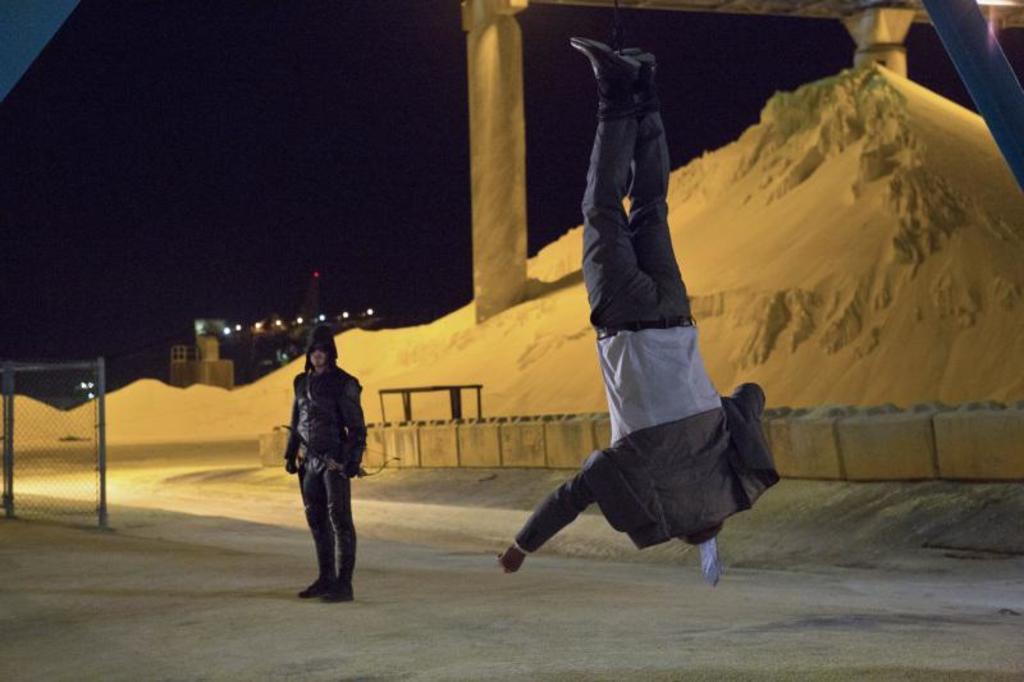How would you summarize this image in a sentence or two? In this image I can see two persons. In front the person is in the air. In the background I can see the sand, few pillars, lights and the sky is in black color. 